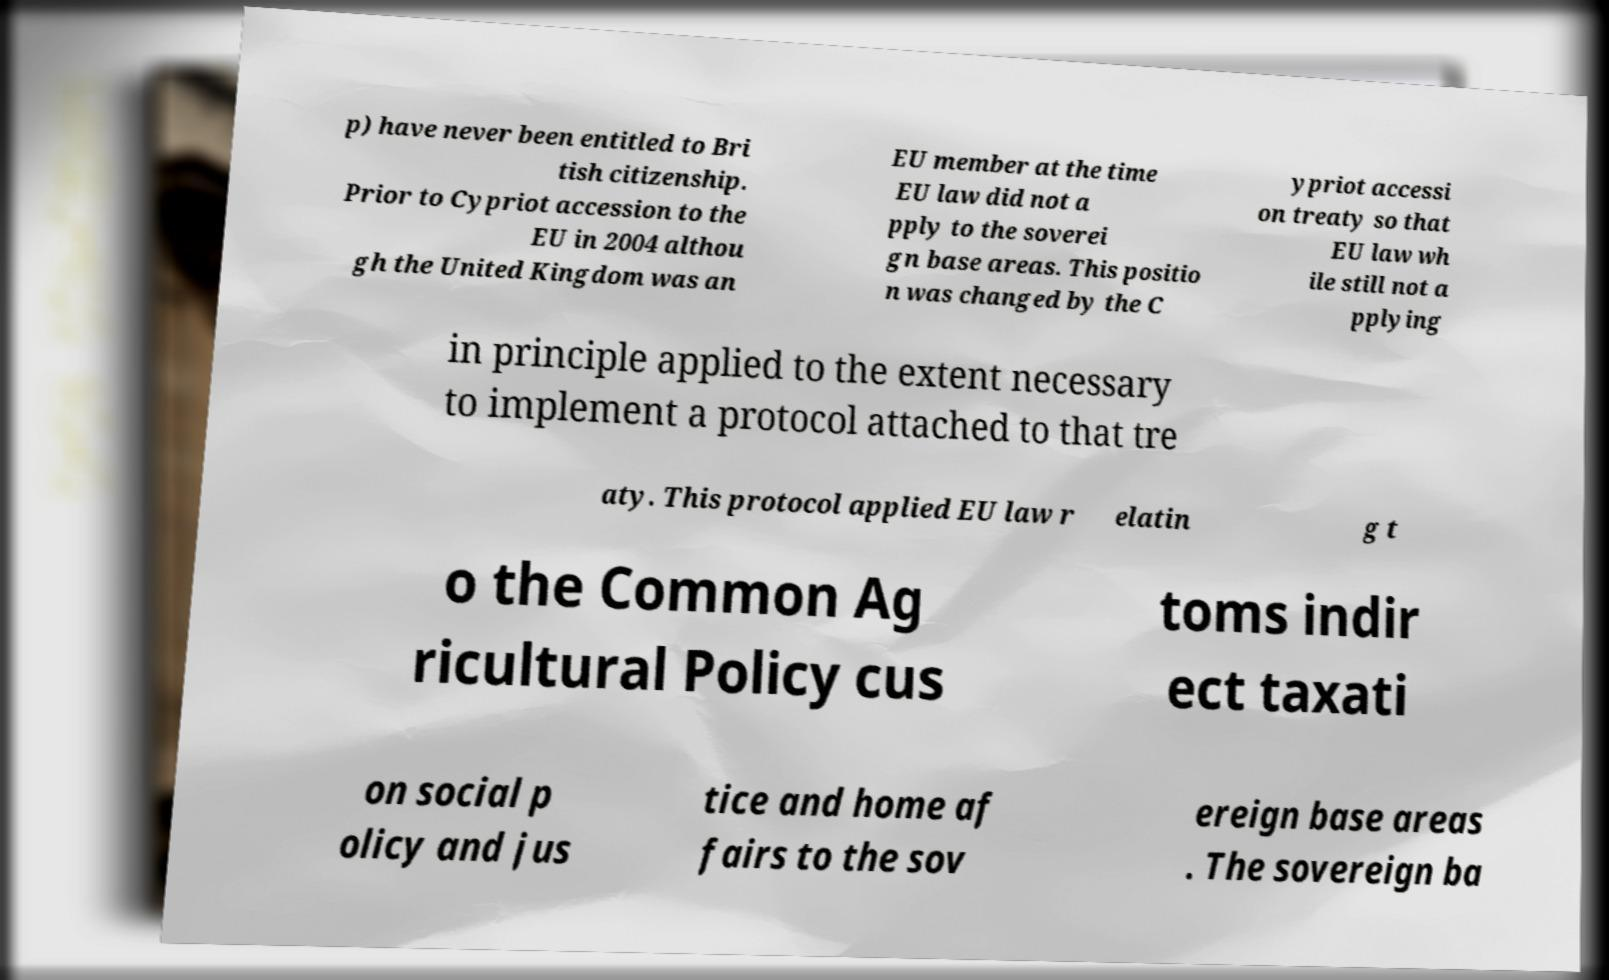I need the written content from this picture converted into text. Can you do that? p) have never been entitled to Bri tish citizenship. Prior to Cypriot accession to the EU in 2004 althou gh the United Kingdom was an EU member at the time EU law did not a pply to the soverei gn base areas. This positio n was changed by the C ypriot accessi on treaty so that EU law wh ile still not a pplying in principle applied to the extent necessary to implement a protocol attached to that tre aty. This protocol applied EU law r elatin g t o the Common Ag ricultural Policy cus toms indir ect taxati on social p olicy and jus tice and home af fairs to the sov ereign base areas . The sovereign ba 